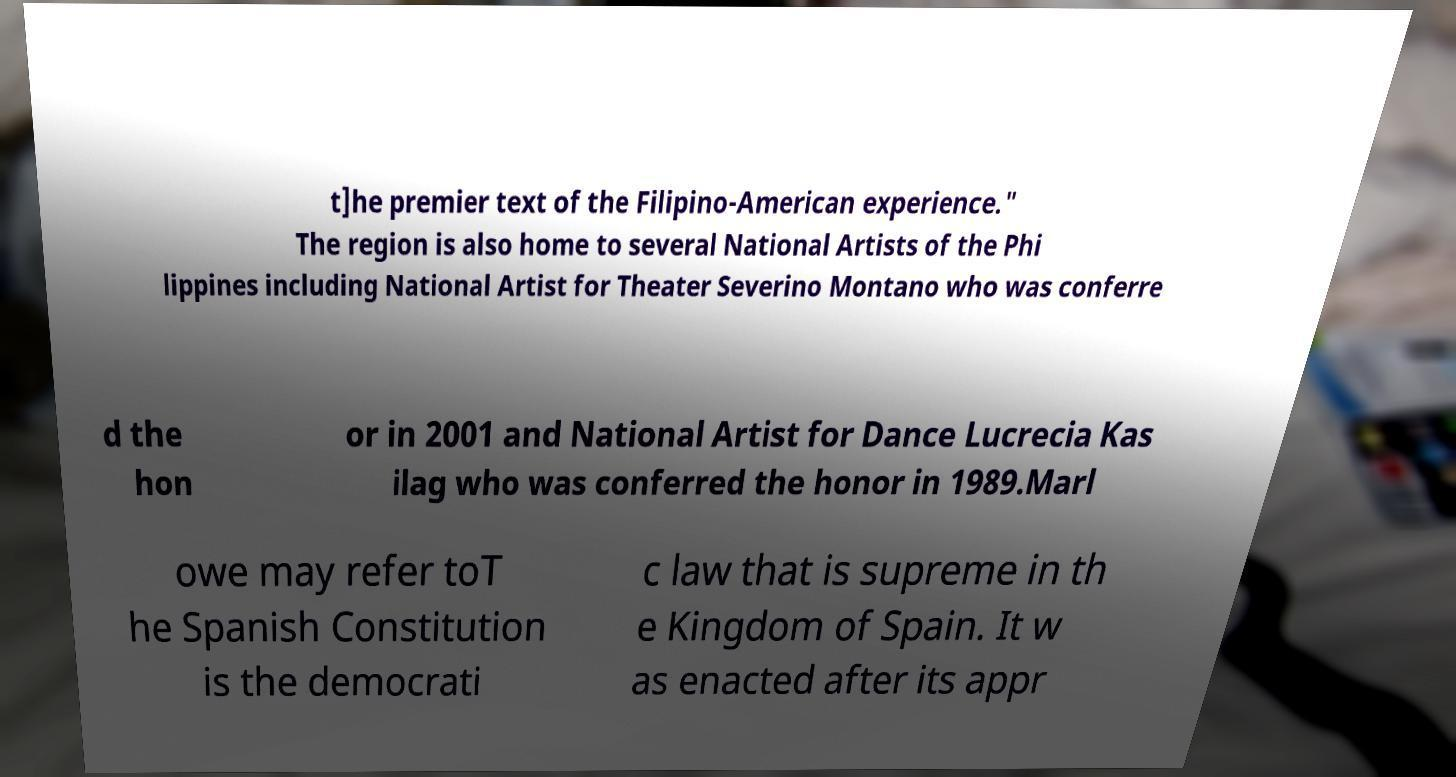Please identify and transcribe the text found in this image. t]he premier text of the Filipino-American experience." The region is also home to several National Artists of the Phi lippines including National Artist for Theater Severino Montano who was conferre d the hon or in 2001 and National Artist for Dance Lucrecia Kas ilag who was conferred the honor in 1989.Marl owe may refer toT he Spanish Constitution is the democrati c law that is supreme in th e Kingdom of Spain. It w as enacted after its appr 